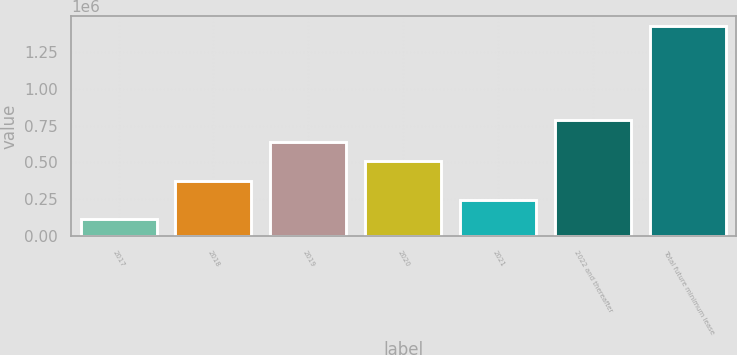Convert chart. <chart><loc_0><loc_0><loc_500><loc_500><bar_chart><fcel>2017<fcel>2018<fcel>2019<fcel>2020<fcel>2021<fcel>2022 and thereafter<fcel>Total future minimum lease<nl><fcel>114857<fcel>376371<fcel>637885<fcel>507128<fcel>245614<fcel>788180<fcel>1.42243e+06<nl></chart> 